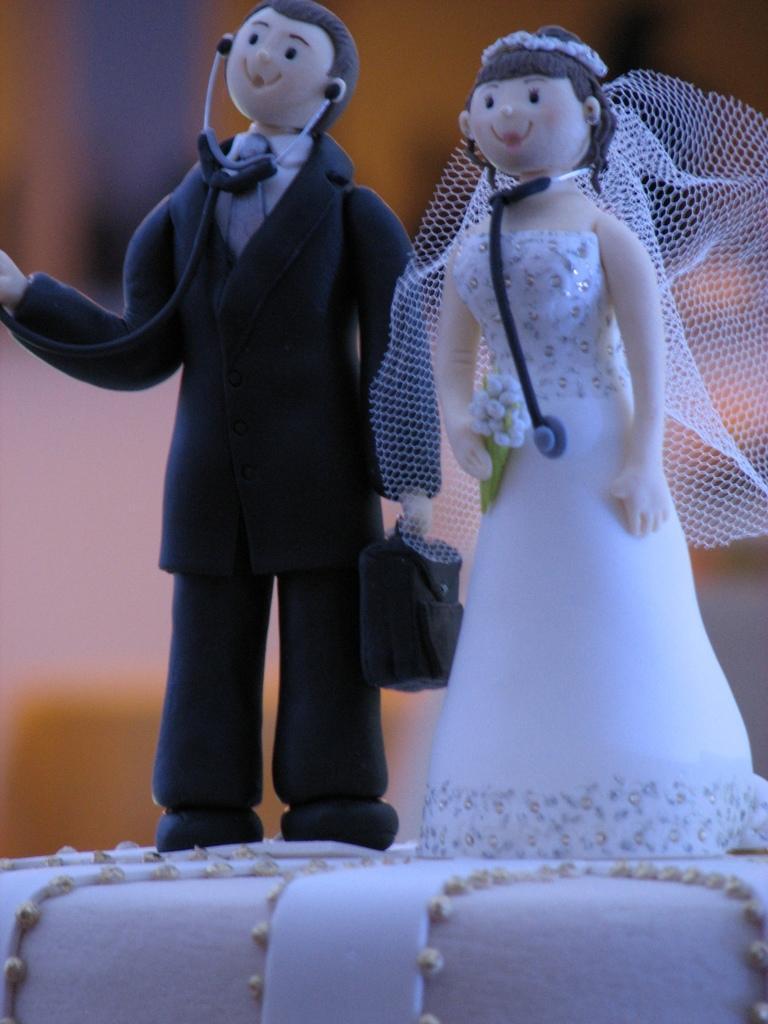Please provide a concise description of this image. In this image there is a cake, where there are two persons standing with the stethoscopes on the cake , which are made up of the cake material, and there is blur background. 